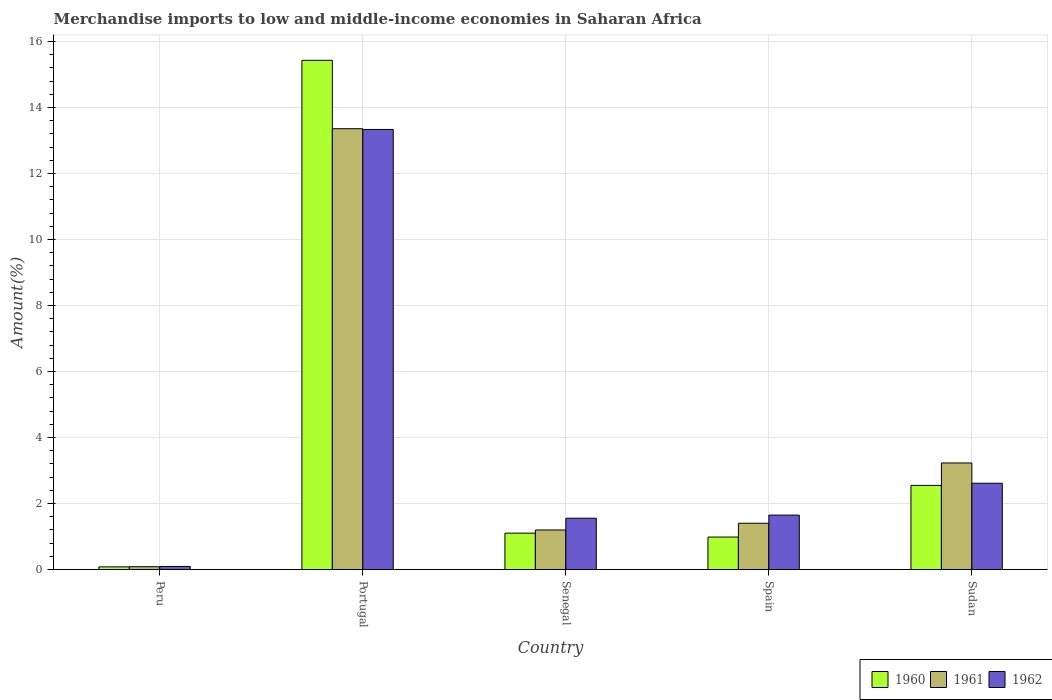How many different coloured bars are there?
Provide a succinct answer. 3. How many bars are there on the 3rd tick from the left?
Ensure brevity in your answer.  3. In how many cases, is the number of bars for a given country not equal to the number of legend labels?
Ensure brevity in your answer.  0. What is the percentage of amount earned from merchandise imports in 1962 in Peru?
Your answer should be compact. 0.09. Across all countries, what is the maximum percentage of amount earned from merchandise imports in 1960?
Provide a short and direct response. 15.43. Across all countries, what is the minimum percentage of amount earned from merchandise imports in 1960?
Your answer should be very brief. 0.08. In which country was the percentage of amount earned from merchandise imports in 1960 maximum?
Ensure brevity in your answer.  Portugal. In which country was the percentage of amount earned from merchandise imports in 1962 minimum?
Offer a terse response. Peru. What is the total percentage of amount earned from merchandise imports in 1962 in the graph?
Your answer should be very brief. 19.24. What is the difference between the percentage of amount earned from merchandise imports in 1962 in Portugal and that in Senegal?
Offer a terse response. 11.78. What is the difference between the percentage of amount earned from merchandise imports in 1961 in Spain and the percentage of amount earned from merchandise imports in 1960 in Portugal?
Provide a short and direct response. -14.02. What is the average percentage of amount earned from merchandise imports in 1961 per country?
Keep it short and to the point. 3.85. What is the difference between the percentage of amount earned from merchandise imports of/in 1962 and percentage of amount earned from merchandise imports of/in 1961 in Peru?
Offer a terse response. 0.01. In how many countries, is the percentage of amount earned from merchandise imports in 1962 greater than 4.8 %?
Keep it short and to the point. 1. What is the ratio of the percentage of amount earned from merchandise imports in 1960 in Peru to that in Spain?
Provide a short and direct response. 0.08. Is the percentage of amount earned from merchandise imports in 1961 in Spain less than that in Sudan?
Your response must be concise. Yes. Is the difference between the percentage of amount earned from merchandise imports in 1962 in Portugal and Sudan greater than the difference between the percentage of amount earned from merchandise imports in 1961 in Portugal and Sudan?
Offer a very short reply. Yes. What is the difference between the highest and the second highest percentage of amount earned from merchandise imports in 1960?
Your response must be concise. -1.45. What is the difference between the highest and the lowest percentage of amount earned from merchandise imports in 1961?
Your response must be concise. 13.27. In how many countries, is the percentage of amount earned from merchandise imports in 1961 greater than the average percentage of amount earned from merchandise imports in 1961 taken over all countries?
Your answer should be very brief. 1. Is the sum of the percentage of amount earned from merchandise imports in 1961 in Senegal and Sudan greater than the maximum percentage of amount earned from merchandise imports in 1960 across all countries?
Ensure brevity in your answer.  No. How many countries are there in the graph?
Offer a terse response. 5. What is the difference between two consecutive major ticks on the Y-axis?
Offer a very short reply. 2. Does the graph contain any zero values?
Make the answer very short. No. Does the graph contain grids?
Provide a succinct answer. Yes. Where does the legend appear in the graph?
Offer a terse response. Bottom right. How many legend labels are there?
Your response must be concise. 3. What is the title of the graph?
Make the answer very short. Merchandise imports to low and middle-income economies in Saharan Africa. What is the label or title of the Y-axis?
Keep it short and to the point. Amount(%). What is the Amount(%) of 1960 in Peru?
Make the answer very short. 0.08. What is the Amount(%) in 1961 in Peru?
Your answer should be compact. 0.09. What is the Amount(%) of 1962 in Peru?
Provide a succinct answer. 0.09. What is the Amount(%) in 1960 in Portugal?
Ensure brevity in your answer.  15.43. What is the Amount(%) in 1961 in Portugal?
Offer a very short reply. 13.35. What is the Amount(%) in 1962 in Portugal?
Make the answer very short. 13.33. What is the Amount(%) of 1960 in Senegal?
Keep it short and to the point. 1.1. What is the Amount(%) of 1961 in Senegal?
Offer a very short reply. 1.2. What is the Amount(%) of 1962 in Senegal?
Ensure brevity in your answer.  1.55. What is the Amount(%) of 1960 in Spain?
Make the answer very short. 0.98. What is the Amount(%) of 1961 in Spain?
Ensure brevity in your answer.  1.4. What is the Amount(%) in 1962 in Spain?
Provide a succinct answer. 1.65. What is the Amount(%) in 1960 in Sudan?
Make the answer very short. 2.55. What is the Amount(%) in 1961 in Sudan?
Offer a very short reply. 3.23. What is the Amount(%) in 1962 in Sudan?
Give a very brief answer. 2.61. Across all countries, what is the maximum Amount(%) in 1960?
Offer a very short reply. 15.43. Across all countries, what is the maximum Amount(%) of 1961?
Your answer should be very brief. 13.35. Across all countries, what is the maximum Amount(%) in 1962?
Your answer should be very brief. 13.33. Across all countries, what is the minimum Amount(%) of 1960?
Provide a succinct answer. 0.08. Across all countries, what is the minimum Amount(%) of 1961?
Provide a short and direct response. 0.09. Across all countries, what is the minimum Amount(%) in 1962?
Your answer should be compact. 0.09. What is the total Amount(%) in 1960 in the graph?
Provide a succinct answer. 20.14. What is the total Amount(%) in 1961 in the graph?
Your response must be concise. 19.27. What is the total Amount(%) in 1962 in the graph?
Give a very brief answer. 19.24. What is the difference between the Amount(%) of 1960 in Peru and that in Portugal?
Keep it short and to the point. -15.35. What is the difference between the Amount(%) in 1961 in Peru and that in Portugal?
Offer a terse response. -13.27. What is the difference between the Amount(%) in 1962 in Peru and that in Portugal?
Offer a very short reply. -13.24. What is the difference between the Amount(%) in 1960 in Peru and that in Senegal?
Provide a short and direct response. -1.02. What is the difference between the Amount(%) in 1961 in Peru and that in Senegal?
Provide a short and direct response. -1.11. What is the difference between the Amount(%) of 1962 in Peru and that in Senegal?
Offer a terse response. -1.46. What is the difference between the Amount(%) of 1960 in Peru and that in Spain?
Give a very brief answer. -0.9. What is the difference between the Amount(%) in 1961 in Peru and that in Spain?
Provide a succinct answer. -1.32. What is the difference between the Amount(%) in 1962 in Peru and that in Spain?
Make the answer very short. -1.56. What is the difference between the Amount(%) in 1960 in Peru and that in Sudan?
Your response must be concise. -2.47. What is the difference between the Amount(%) in 1961 in Peru and that in Sudan?
Offer a very short reply. -3.14. What is the difference between the Amount(%) in 1962 in Peru and that in Sudan?
Your answer should be compact. -2.52. What is the difference between the Amount(%) in 1960 in Portugal and that in Senegal?
Make the answer very short. 14.32. What is the difference between the Amount(%) of 1961 in Portugal and that in Senegal?
Make the answer very short. 12.16. What is the difference between the Amount(%) of 1962 in Portugal and that in Senegal?
Give a very brief answer. 11.78. What is the difference between the Amount(%) in 1960 in Portugal and that in Spain?
Make the answer very short. 14.44. What is the difference between the Amount(%) in 1961 in Portugal and that in Spain?
Ensure brevity in your answer.  11.95. What is the difference between the Amount(%) in 1962 in Portugal and that in Spain?
Provide a succinct answer. 11.68. What is the difference between the Amount(%) in 1960 in Portugal and that in Sudan?
Provide a short and direct response. 12.88. What is the difference between the Amount(%) in 1961 in Portugal and that in Sudan?
Give a very brief answer. 10.13. What is the difference between the Amount(%) of 1962 in Portugal and that in Sudan?
Your answer should be compact. 10.72. What is the difference between the Amount(%) of 1960 in Senegal and that in Spain?
Give a very brief answer. 0.12. What is the difference between the Amount(%) of 1961 in Senegal and that in Spain?
Your answer should be very brief. -0.2. What is the difference between the Amount(%) of 1962 in Senegal and that in Spain?
Your answer should be very brief. -0.09. What is the difference between the Amount(%) of 1960 in Senegal and that in Sudan?
Your answer should be compact. -1.45. What is the difference between the Amount(%) in 1961 in Senegal and that in Sudan?
Your response must be concise. -2.03. What is the difference between the Amount(%) of 1962 in Senegal and that in Sudan?
Make the answer very short. -1.06. What is the difference between the Amount(%) of 1960 in Spain and that in Sudan?
Give a very brief answer. -1.56. What is the difference between the Amount(%) of 1961 in Spain and that in Sudan?
Offer a terse response. -1.83. What is the difference between the Amount(%) in 1962 in Spain and that in Sudan?
Offer a terse response. -0.97. What is the difference between the Amount(%) in 1960 in Peru and the Amount(%) in 1961 in Portugal?
Your answer should be compact. -13.27. What is the difference between the Amount(%) of 1960 in Peru and the Amount(%) of 1962 in Portugal?
Give a very brief answer. -13.25. What is the difference between the Amount(%) of 1961 in Peru and the Amount(%) of 1962 in Portugal?
Give a very brief answer. -13.25. What is the difference between the Amount(%) of 1960 in Peru and the Amount(%) of 1961 in Senegal?
Your response must be concise. -1.12. What is the difference between the Amount(%) in 1960 in Peru and the Amount(%) in 1962 in Senegal?
Keep it short and to the point. -1.47. What is the difference between the Amount(%) of 1961 in Peru and the Amount(%) of 1962 in Senegal?
Provide a short and direct response. -1.47. What is the difference between the Amount(%) in 1960 in Peru and the Amount(%) in 1961 in Spain?
Your response must be concise. -1.32. What is the difference between the Amount(%) in 1960 in Peru and the Amount(%) in 1962 in Spain?
Make the answer very short. -1.57. What is the difference between the Amount(%) of 1961 in Peru and the Amount(%) of 1962 in Spain?
Offer a terse response. -1.56. What is the difference between the Amount(%) of 1960 in Peru and the Amount(%) of 1961 in Sudan?
Keep it short and to the point. -3.15. What is the difference between the Amount(%) of 1960 in Peru and the Amount(%) of 1962 in Sudan?
Offer a terse response. -2.53. What is the difference between the Amount(%) in 1961 in Peru and the Amount(%) in 1962 in Sudan?
Make the answer very short. -2.53. What is the difference between the Amount(%) of 1960 in Portugal and the Amount(%) of 1961 in Senegal?
Offer a very short reply. 14.23. What is the difference between the Amount(%) in 1960 in Portugal and the Amount(%) in 1962 in Senegal?
Your answer should be compact. 13.87. What is the difference between the Amount(%) of 1961 in Portugal and the Amount(%) of 1962 in Senegal?
Your answer should be compact. 11.8. What is the difference between the Amount(%) of 1960 in Portugal and the Amount(%) of 1961 in Spain?
Your response must be concise. 14.02. What is the difference between the Amount(%) in 1960 in Portugal and the Amount(%) in 1962 in Spain?
Keep it short and to the point. 13.78. What is the difference between the Amount(%) in 1961 in Portugal and the Amount(%) in 1962 in Spain?
Keep it short and to the point. 11.71. What is the difference between the Amount(%) of 1960 in Portugal and the Amount(%) of 1961 in Sudan?
Provide a short and direct response. 12.2. What is the difference between the Amount(%) in 1960 in Portugal and the Amount(%) in 1962 in Sudan?
Your answer should be compact. 12.81. What is the difference between the Amount(%) of 1961 in Portugal and the Amount(%) of 1962 in Sudan?
Offer a terse response. 10.74. What is the difference between the Amount(%) of 1960 in Senegal and the Amount(%) of 1961 in Spain?
Provide a succinct answer. -0.3. What is the difference between the Amount(%) in 1960 in Senegal and the Amount(%) in 1962 in Spain?
Your answer should be very brief. -0.55. What is the difference between the Amount(%) of 1961 in Senegal and the Amount(%) of 1962 in Spain?
Keep it short and to the point. -0.45. What is the difference between the Amount(%) in 1960 in Senegal and the Amount(%) in 1961 in Sudan?
Your response must be concise. -2.13. What is the difference between the Amount(%) of 1960 in Senegal and the Amount(%) of 1962 in Sudan?
Keep it short and to the point. -1.51. What is the difference between the Amount(%) of 1961 in Senegal and the Amount(%) of 1962 in Sudan?
Offer a very short reply. -1.42. What is the difference between the Amount(%) in 1960 in Spain and the Amount(%) in 1961 in Sudan?
Your response must be concise. -2.24. What is the difference between the Amount(%) in 1960 in Spain and the Amount(%) in 1962 in Sudan?
Give a very brief answer. -1.63. What is the difference between the Amount(%) of 1961 in Spain and the Amount(%) of 1962 in Sudan?
Give a very brief answer. -1.21. What is the average Amount(%) in 1960 per country?
Your answer should be compact. 4.03. What is the average Amount(%) in 1961 per country?
Provide a short and direct response. 3.85. What is the average Amount(%) in 1962 per country?
Your answer should be very brief. 3.85. What is the difference between the Amount(%) of 1960 and Amount(%) of 1961 in Peru?
Make the answer very short. -0. What is the difference between the Amount(%) in 1960 and Amount(%) in 1962 in Peru?
Provide a short and direct response. -0.01. What is the difference between the Amount(%) in 1961 and Amount(%) in 1962 in Peru?
Your answer should be compact. -0.01. What is the difference between the Amount(%) of 1960 and Amount(%) of 1961 in Portugal?
Your answer should be compact. 2.07. What is the difference between the Amount(%) of 1960 and Amount(%) of 1962 in Portugal?
Provide a short and direct response. 2.09. What is the difference between the Amount(%) in 1961 and Amount(%) in 1962 in Portugal?
Provide a short and direct response. 0.02. What is the difference between the Amount(%) in 1960 and Amount(%) in 1961 in Senegal?
Give a very brief answer. -0.1. What is the difference between the Amount(%) in 1960 and Amount(%) in 1962 in Senegal?
Provide a short and direct response. -0.45. What is the difference between the Amount(%) in 1961 and Amount(%) in 1962 in Senegal?
Your answer should be compact. -0.36. What is the difference between the Amount(%) of 1960 and Amount(%) of 1961 in Spain?
Ensure brevity in your answer.  -0.42. What is the difference between the Amount(%) of 1960 and Amount(%) of 1962 in Spain?
Offer a very short reply. -0.66. What is the difference between the Amount(%) of 1961 and Amount(%) of 1962 in Spain?
Keep it short and to the point. -0.25. What is the difference between the Amount(%) in 1960 and Amount(%) in 1961 in Sudan?
Ensure brevity in your answer.  -0.68. What is the difference between the Amount(%) in 1960 and Amount(%) in 1962 in Sudan?
Your answer should be compact. -0.07. What is the difference between the Amount(%) of 1961 and Amount(%) of 1962 in Sudan?
Your answer should be compact. 0.61. What is the ratio of the Amount(%) in 1960 in Peru to that in Portugal?
Offer a terse response. 0.01. What is the ratio of the Amount(%) in 1961 in Peru to that in Portugal?
Provide a succinct answer. 0.01. What is the ratio of the Amount(%) in 1962 in Peru to that in Portugal?
Provide a short and direct response. 0.01. What is the ratio of the Amount(%) in 1960 in Peru to that in Senegal?
Provide a succinct answer. 0.07. What is the ratio of the Amount(%) of 1961 in Peru to that in Senegal?
Provide a short and direct response. 0.07. What is the ratio of the Amount(%) in 1962 in Peru to that in Senegal?
Provide a short and direct response. 0.06. What is the ratio of the Amount(%) in 1960 in Peru to that in Spain?
Your answer should be compact. 0.08. What is the ratio of the Amount(%) of 1961 in Peru to that in Spain?
Keep it short and to the point. 0.06. What is the ratio of the Amount(%) of 1962 in Peru to that in Spain?
Provide a short and direct response. 0.06. What is the ratio of the Amount(%) of 1960 in Peru to that in Sudan?
Make the answer very short. 0.03. What is the ratio of the Amount(%) in 1961 in Peru to that in Sudan?
Offer a terse response. 0.03. What is the ratio of the Amount(%) in 1962 in Peru to that in Sudan?
Your answer should be very brief. 0.04. What is the ratio of the Amount(%) of 1960 in Portugal to that in Senegal?
Ensure brevity in your answer.  14. What is the ratio of the Amount(%) in 1961 in Portugal to that in Senegal?
Keep it short and to the point. 11.15. What is the ratio of the Amount(%) of 1962 in Portugal to that in Senegal?
Offer a very short reply. 8.58. What is the ratio of the Amount(%) of 1960 in Portugal to that in Spain?
Provide a short and direct response. 15.68. What is the ratio of the Amount(%) in 1961 in Portugal to that in Spain?
Your answer should be very brief. 9.52. What is the ratio of the Amount(%) in 1962 in Portugal to that in Spain?
Your response must be concise. 8.09. What is the ratio of the Amount(%) of 1960 in Portugal to that in Sudan?
Your answer should be very brief. 6.05. What is the ratio of the Amount(%) of 1961 in Portugal to that in Sudan?
Your answer should be compact. 4.14. What is the ratio of the Amount(%) in 1962 in Portugal to that in Sudan?
Ensure brevity in your answer.  5.1. What is the ratio of the Amount(%) in 1960 in Senegal to that in Spain?
Your answer should be very brief. 1.12. What is the ratio of the Amount(%) of 1961 in Senegal to that in Spain?
Provide a succinct answer. 0.85. What is the ratio of the Amount(%) of 1962 in Senegal to that in Spain?
Provide a succinct answer. 0.94. What is the ratio of the Amount(%) in 1960 in Senegal to that in Sudan?
Provide a succinct answer. 0.43. What is the ratio of the Amount(%) in 1961 in Senegal to that in Sudan?
Offer a terse response. 0.37. What is the ratio of the Amount(%) of 1962 in Senegal to that in Sudan?
Give a very brief answer. 0.59. What is the ratio of the Amount(%) of 1960 in Spain to that in Sudan?
Your answer should be compact. 0.39. What is the ratio of the Amount(%) of 1961 in Spain to that in Sudan?
Offer a very short reply. 0.43. What is the ratio of the Amount(%) of 1962 in Spain to that in Sudan?
Give a very brief answer. 0.63. What is the difference between the highest and the second highest Amount(%) of 1960?
Provide a short and direct response. 12.88. What is the difference between the highest and the second highest Amount(%) of 1961?
Offer a very short reply. 10.13. What is the difference between the highest and the second highest Amount(%) in 1962?
Your answer should be very brief. 10.72. What is the difference between the highest and the lowest Amount(%) of 1960?
Provide a succinct answer. 15.35. What is the difference between the highest and the lowest Amount(%) in 1961?
Make the answer very short. 13.27. What is the difference between the highest and the lowest Amount(%) of 1962?
Offer a terse response. 13.24. 